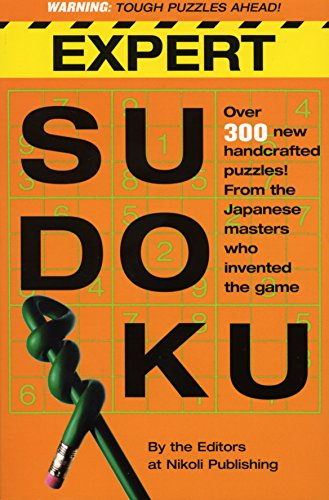What is the title of this book? The title of the book featured in the image is 'Expert Sudoku,' prominently displayed in a bold, large font on the cover. 